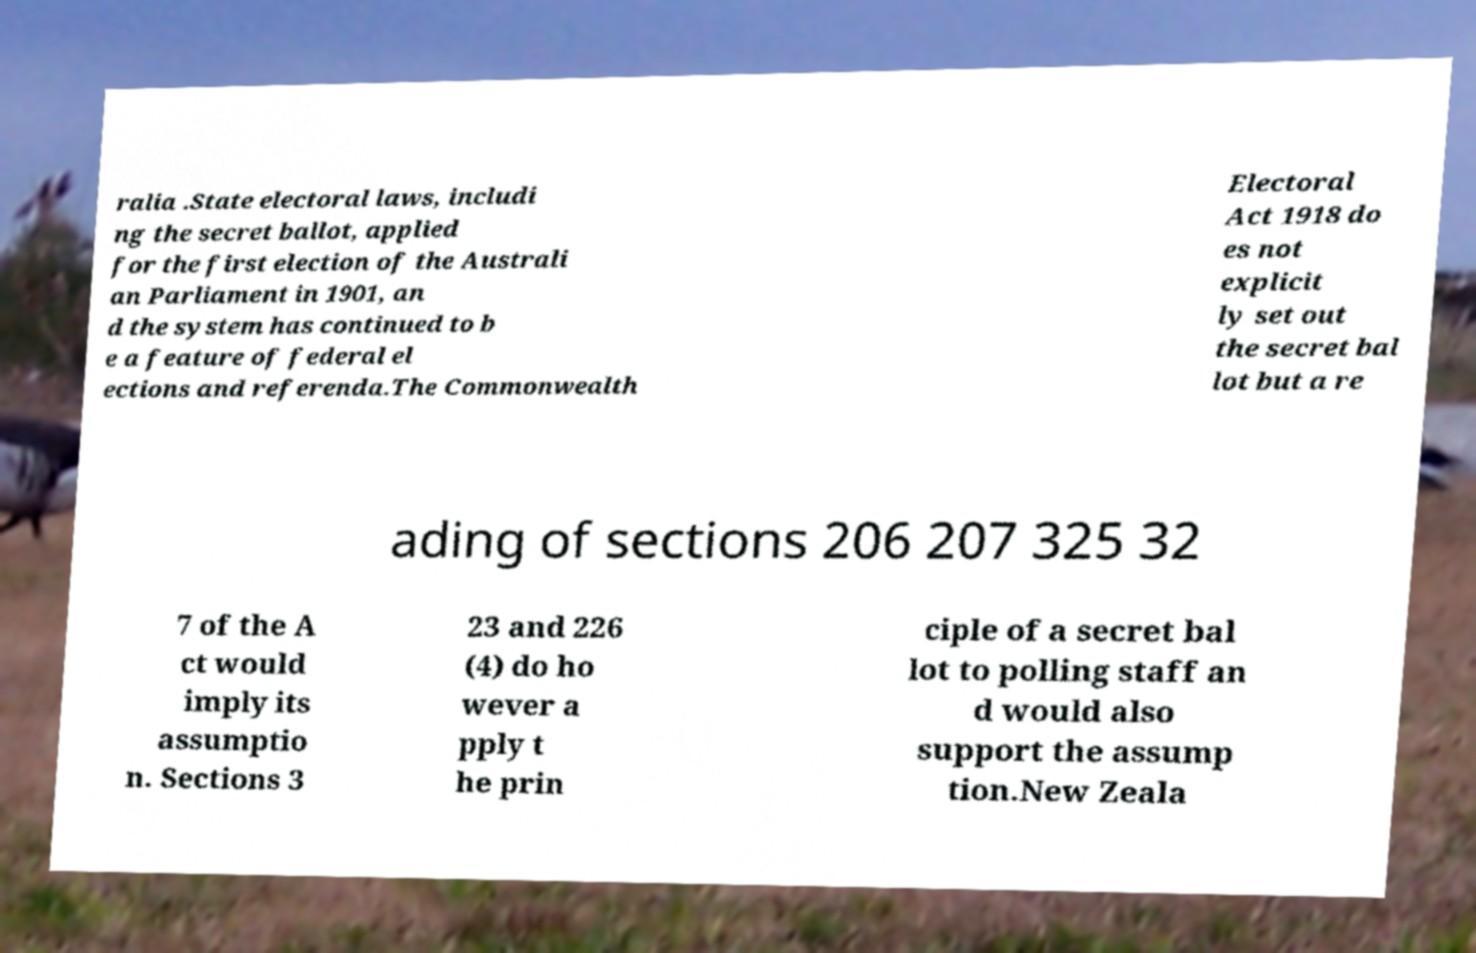Can you accurately transcribe the text from the provided image for me? ralia .State electoral laws, includi ng the secret ballot, applied for the first election of the Australi an Parliament in 1901, an d the system has continued to b e a feature of federal el ections and referenda.The Commonwealth Electoral Act 1918 do es not explicit ly set out the secret bal lot but a re ading of sections 206 207 325 32 7 of the A ct would imply its assumptio n. Sections 3 23 and 226 (4) do ho wever a pply t he prin ciple of a secret bal lot to polling staff an d would also support the assump tion.New Zeala 